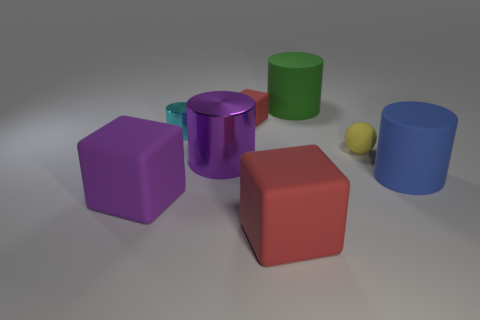How many red blocks must be subtracted to get 1 red blocks? 1 Add 1 yellow rubber objects. How many objects exist? 9 Subtract all blocks. How many objects are left? 5 Add 7 tiny yellow rubber objects. How many tiny yellow rubber objects are left? 8 Add 4 purple objects. How many purple objects exist? 6 Subtract 1 purple cubes. How many objects are left? 7 Subtract all tiny red objects. Subtract all big gray balls. How many objects are left? 7 